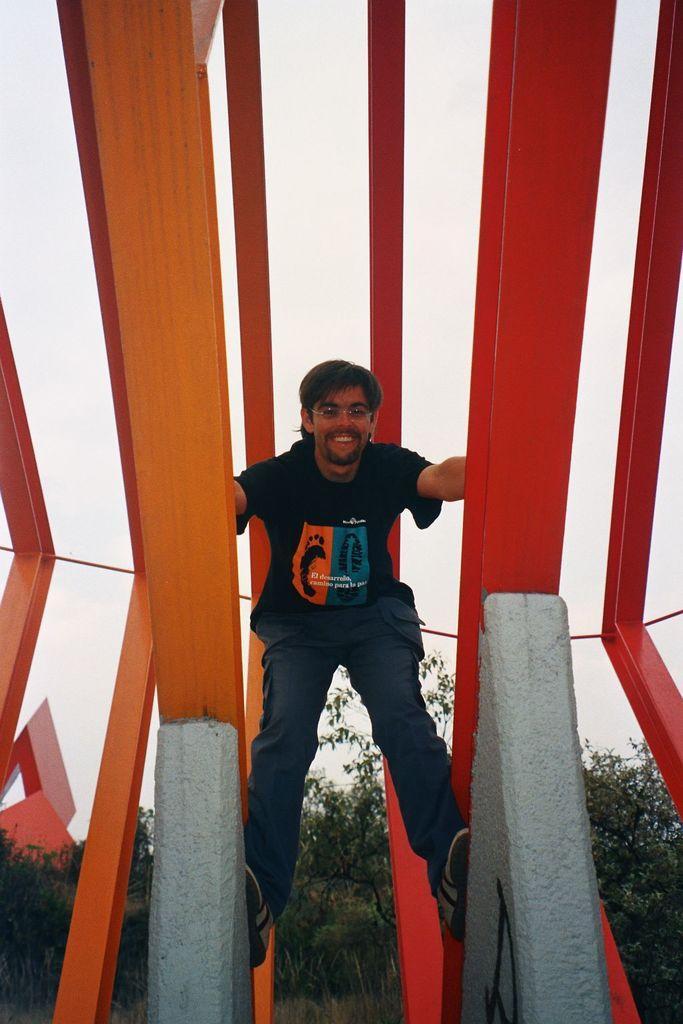Can you describe this image briefly? In the middle of the picture, we see a man in the black T-shirt who is wearing the spectacles is smiling. I think he is climbing the walls or rods. Beside him, we see the rods in red and orange color. We see a rope in orange color. There are trees in the background. At the top, we see the sky. 